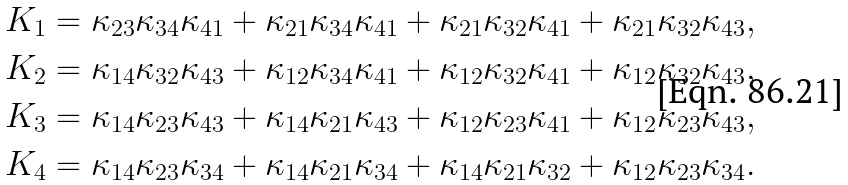<formula> <loc_0><loc_0><loc_500><loc_500>K _ { 1 } = \kappa _ { 2 3 } \kappa _ { 3 4 } \kappa _ { 4 1 } + \kappa _ { 2 1 } \kappa _ { 3 4 } \kappa _ { 4 1 } + \kappa _ { 2 1 } \kappa _ { 3 2 } \kappa _ { 4 1 } + \kappa _ { 2 1 } \kappa _ { 3 2 } \kappa _ { 4 3 } , \\ K _ { 2 } = \kappa _ { 1 4 } \kappa _ { 3 2 } \kappa _ { 4 3 } + \kappa _ { 1 2 } \kappa _ { 3 4 } \kappa _ { 4 1 } + \kappa _ { 1 2 } \kappa _ { 3 2 } \kappa _ { 4 1 } + \kappa _ { 1 2 } \kappa _ { 3 2 } \kappa _ { 4 3 } , \\ K _ { 3 } = \kappa _ { 1 4 } \kappa _ { 2 3 } \kappa _ { 4 3 } + \kappa _ { 1 4 } \kappa _ { 2 1 } \kappa _ { 4 3 } + \kappa _ { 1 2 } \kappa _ { 2 3 } \kappa _ { 4 1 } + \kappa _ { 1 2 } \kappa _ { 2 3 } \kappa _ { 4 3 } , \\ K _ { 4 } = \kappa _ { 1 4 } \kappa _ { 2 3 } \kappa _ { 3 4 } + \kappa _ { 1 4 } \kappa _ { 2 1 } \kappa _ { 3 4 } + \kappa _ { 1 4 } \kappa _ { 2 1 } \kappa _ { 3 2 } + \kappa _ { 1 2 } \kappa _ { 2 3 } \kappa _ { 3 4 } .</formula> 